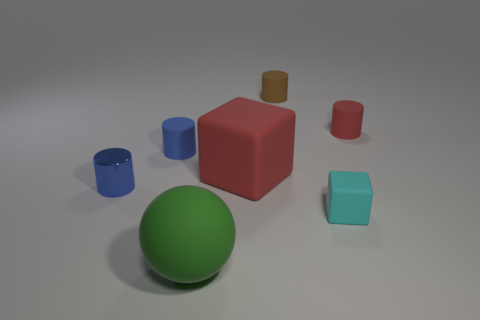Subtract all matte cylinders. How many cylinders are left? 1 Subtract all green spheres. How many blue cylinders are left? 2 Subtract all brown cylinders. How many cylinders are left? 3 Add 2 small purple metallic objects. How many objects exist? 9 Subtract all gray cylinders. Subtract all gray blocks. How many cylinders are left? 4 Subtract all blocks. How many objects are left? 5 Subtract all tiny cyan things. Subtract all small blue cylinders. How many objects are left? 4 Add 4 matte objects. How many matte objects are left? 10 Add 7 gray rubber cylinders. How many gray rubber cylinders exist? 7 Subtract 1 red cylinders. How many objects are left? 6 